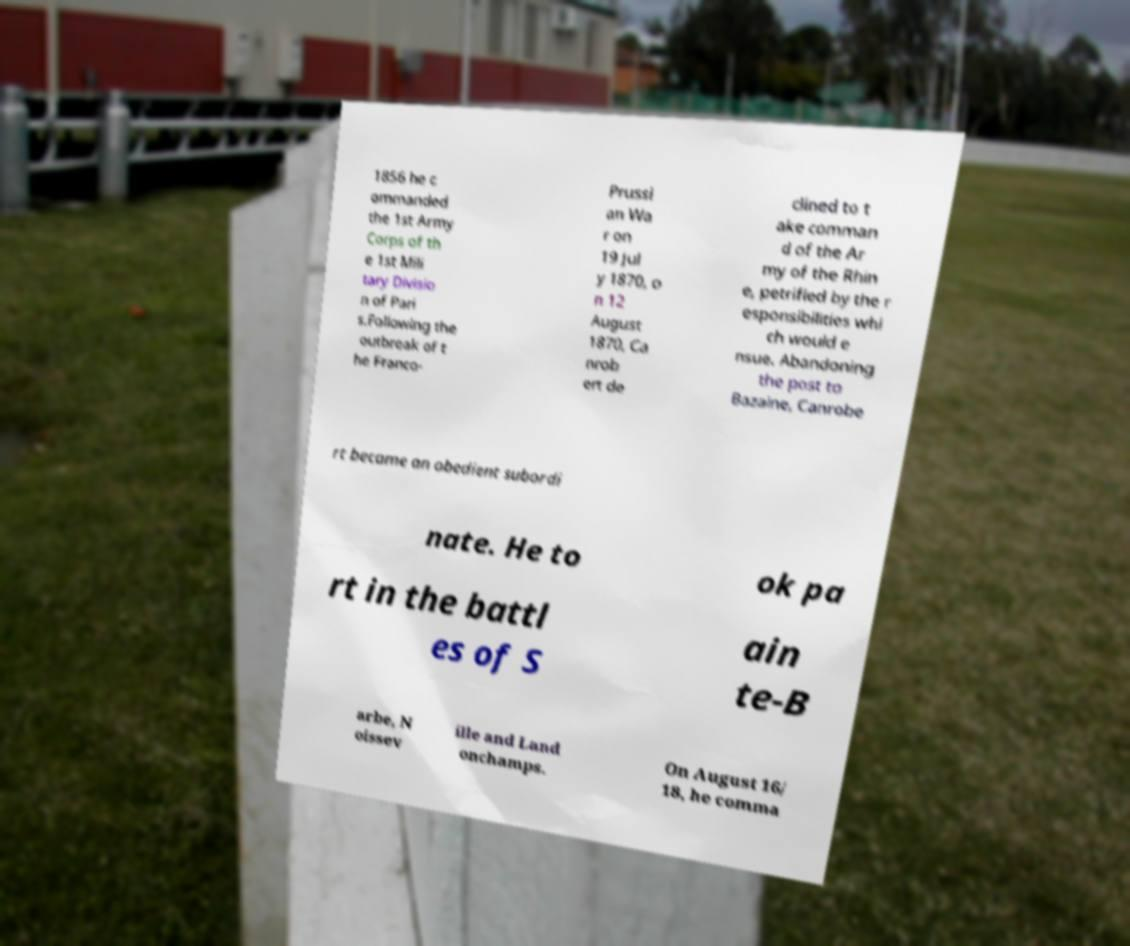Can you accurately transcribe the text from the provided image for me? 1856 he c ommanded the 1st Army Corps of th e 1st Mili tary Divisio n of Pari s.Following the outbreak of t he Franco- Prussi an Wa r on 19 Jul y 1870, o n 12 August 1870, Ca nrob ert de clined to t ake comman d of the Ar my of the Rhin e, petrified by the r esponsibilities whi ch would e nsue. Abandoning the post to Bazaine, Canrobe rt became an obedient subordi nate. He to ok pa rt in the battl es of S ain te-B arbe, N oissev ille and Land onchamps. On August 16/ 18, he comma 